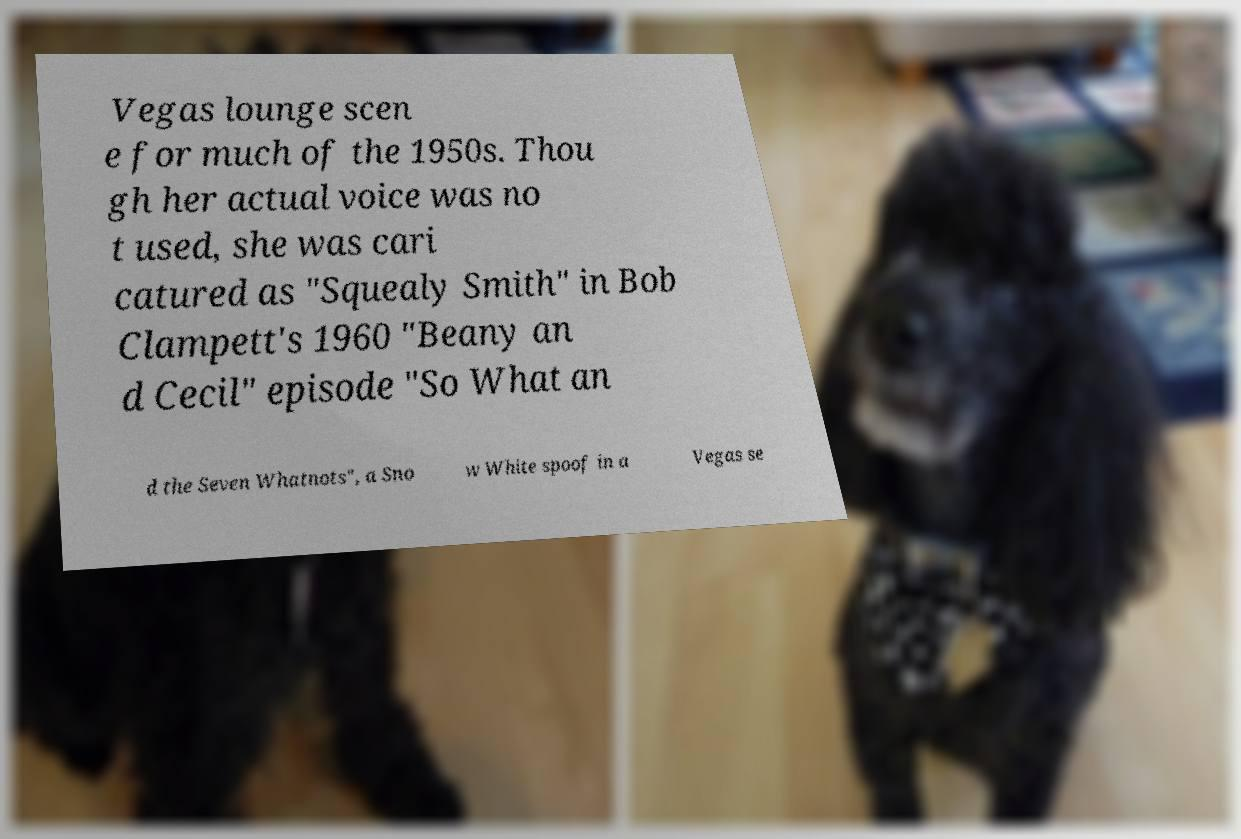Can you accurately transcribe the text from the provided image for me? Vegas lounge scen e for much of the 1950s. Thou gh her actual voice was no t used, she was cari catured as "Squealy Smith" in Bob Clampett's 1960 "Beany an d Cecil" episode "So What an d the Seven Whatnots", a Sno w White spoof in a Vegas se 